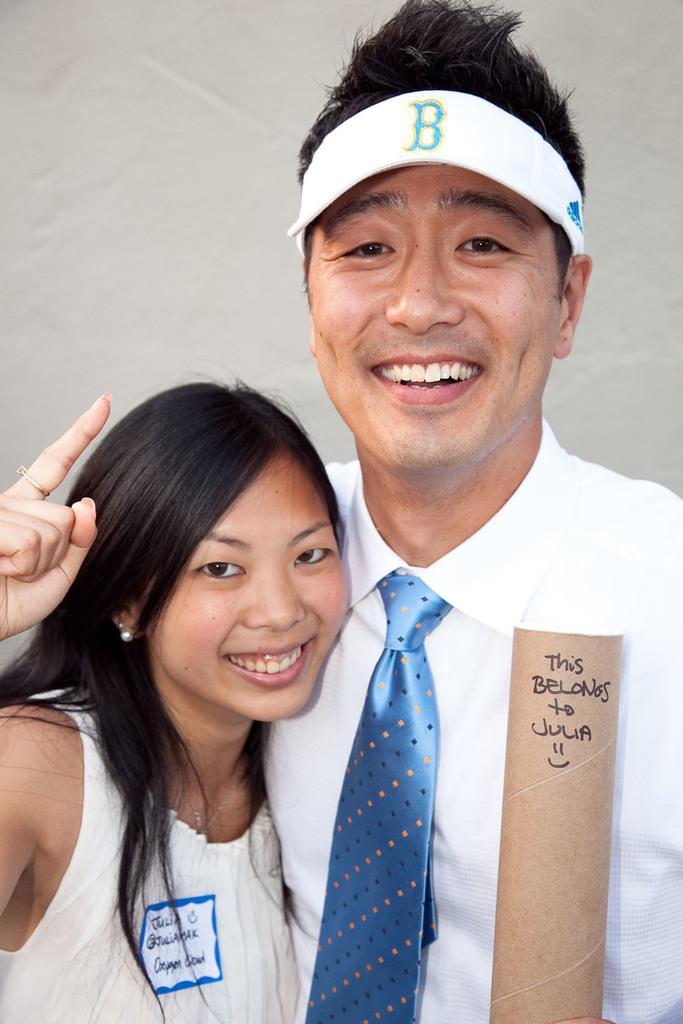Describe this image in one or two sentences. As we can see in the image there is a wall and two people standing in the front. These two are wearing white color dresses. 